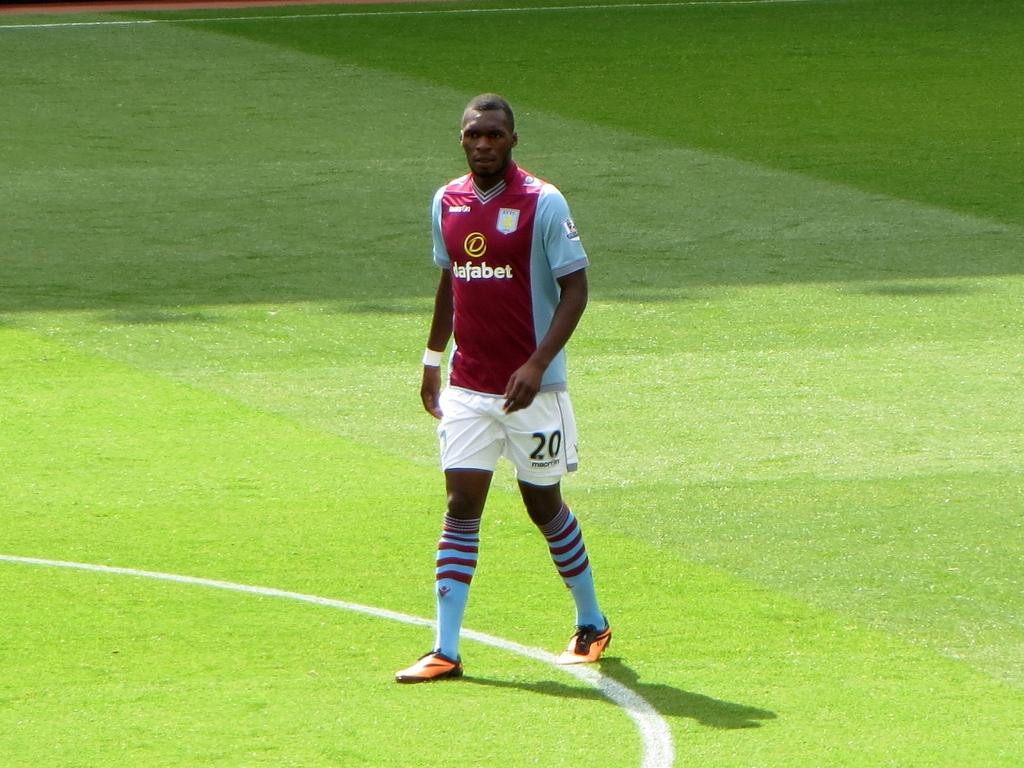<image>
Give a short and clear explanation of the subsequent image. A soccer player, with white shorts bearing the number 20, stands on a field. 